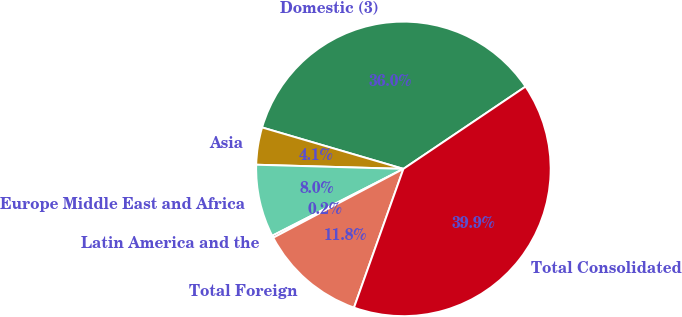<chart> <loc_0><loc_0><loc_500><loc_500><pie_chart><fcel>Domestic (3)<fcel>Asia<fcel>Europe Middle East and Africa<fcel>Latin America and the<fcel>Total Foreign<fcel>Total Consolidated<nl><fcel>36.02%<fcel>4.09%<fcel>7.95%<fcel>0.24%<fcel>11.81%<fcel>39.88%<nl></chart> 